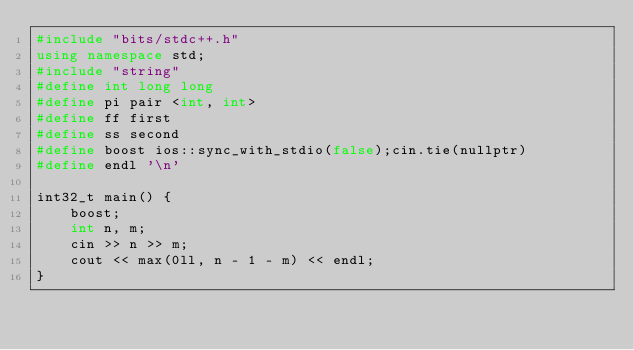<code> <loc_0><loc_0><loc_500><loc_500><_C++_>#include "bits/stdc++.h"
using namespace std;
#include "string"
#define int long long
#define pi pair <int, int>
#define ff first
#define ss second
#define boost ios::sync_with_stdio(false);cin.tie(nullptr)
#define endl '\n'

int32_t main() {
	boost;
	int n, m;
	cin >> n >> m;
	cout << max(0ll, n - 1 - m) << endl;
}</code> 